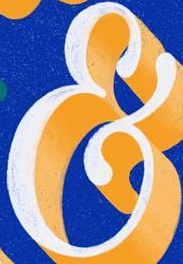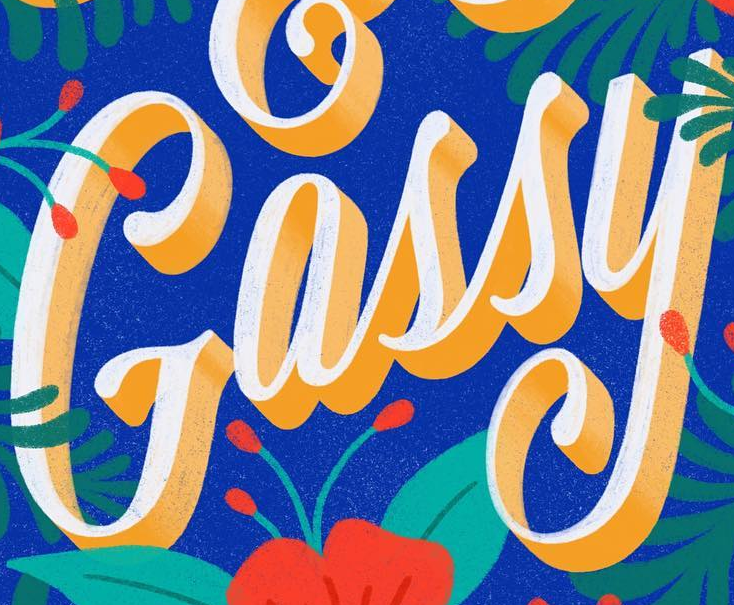What text appears in these images from left to right, separated by a semicolon? &; Gassy 